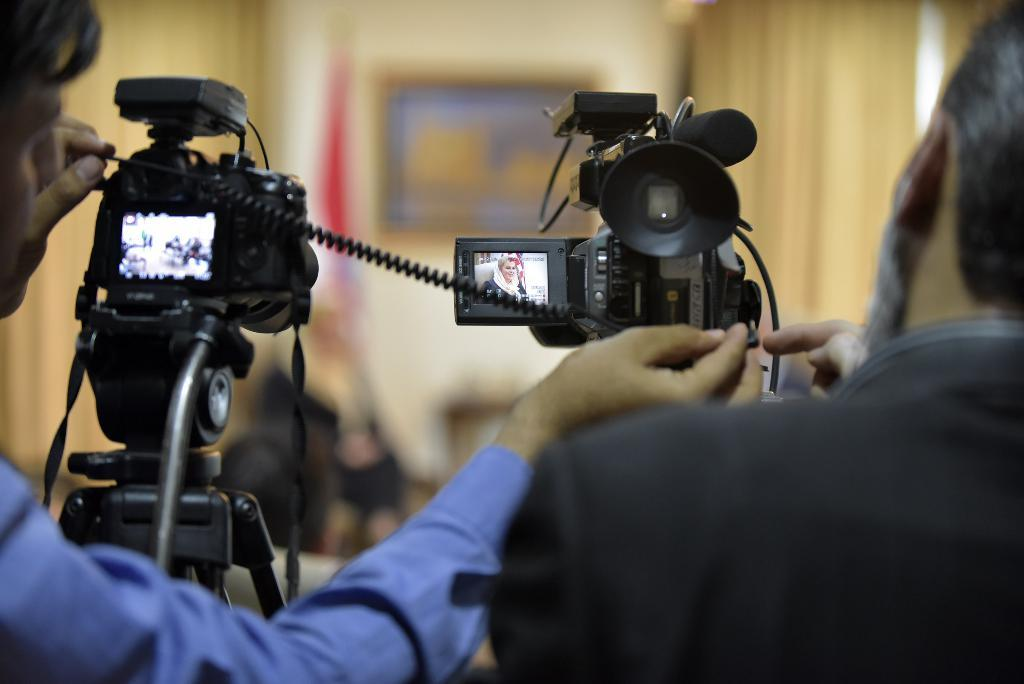How many people are in the image? There are two persons standing in the image. What are the persons holding in their hands? The persons are holding cameras. What can be seen in the background of the image? There is a flag and a photo frame on the wall in the background of the image. What type of wood is used to make the twig that the committee is holding in the image? There is no wood, twig, or committee present in the image. 